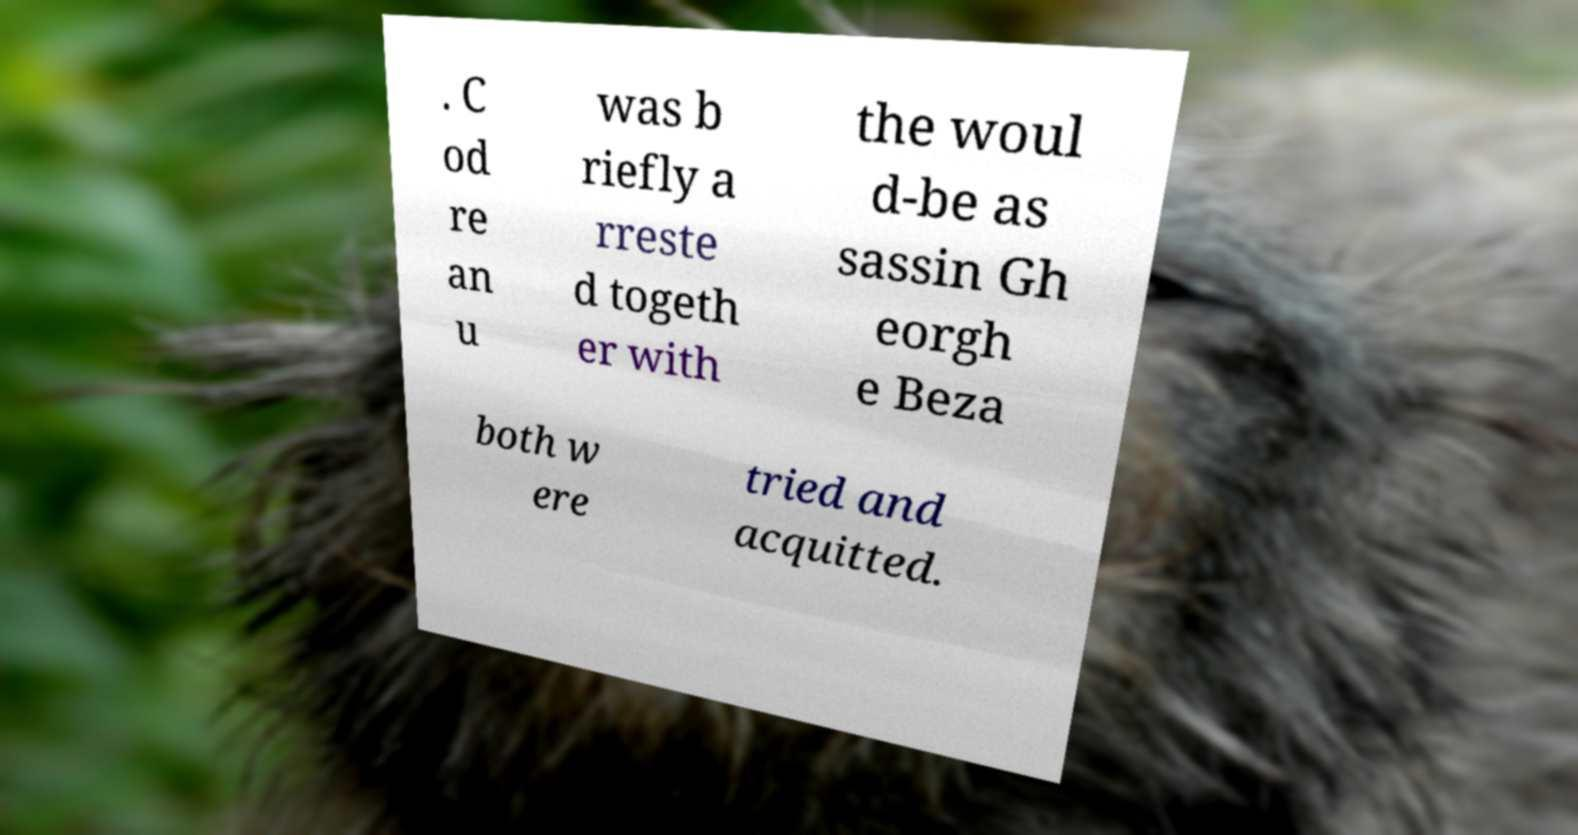Please read and relay the text visible in this image. What does it say? . C od re an u was b riefly a rreste d togeth er with the woul d-be as sassin Gh eorgh e Beza both w ere tried and acquitted. 